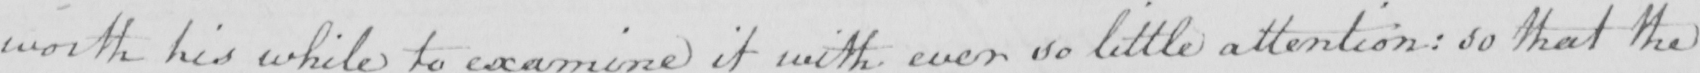Can you tell me what this handwritten text says? worth his while to examine it with ever so little attention :  so that the 